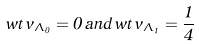<formula> <loc_0><loc_0><loc_500><loc_500>w t \, v _ { \Lambda _ { 0 } } = 0 \, a n d \, w t \, v _ { \Lambda _ { 1 } } = \frac { 1 } { 4 }</formula> 